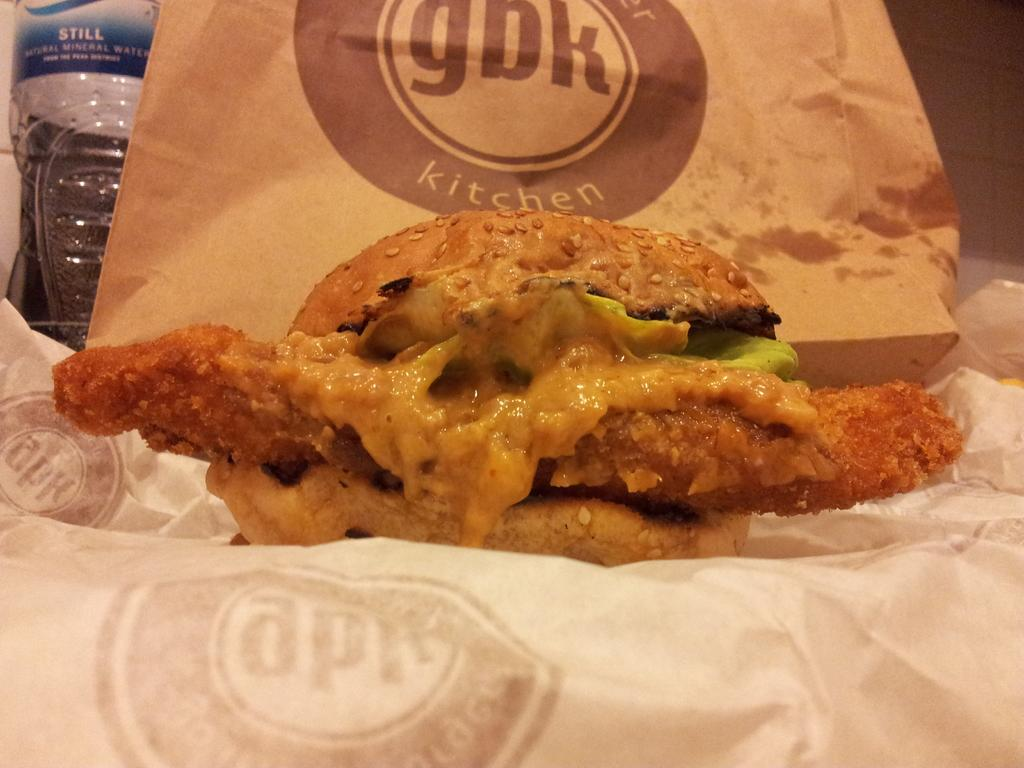What is the main subject of the image? The main subject of the image is food. How is the food being stored or carried? The food is wrapped in paper. What other items can be seen in the backdrop of the image? There is a carry bag and a water bottle in the backdrop of the image. What type of disease is affecting the food in the image? There is no indication of any disease affecting the food in the image. Who is the owner of the food in the image? The image does not provide any information about the owner of the food. 